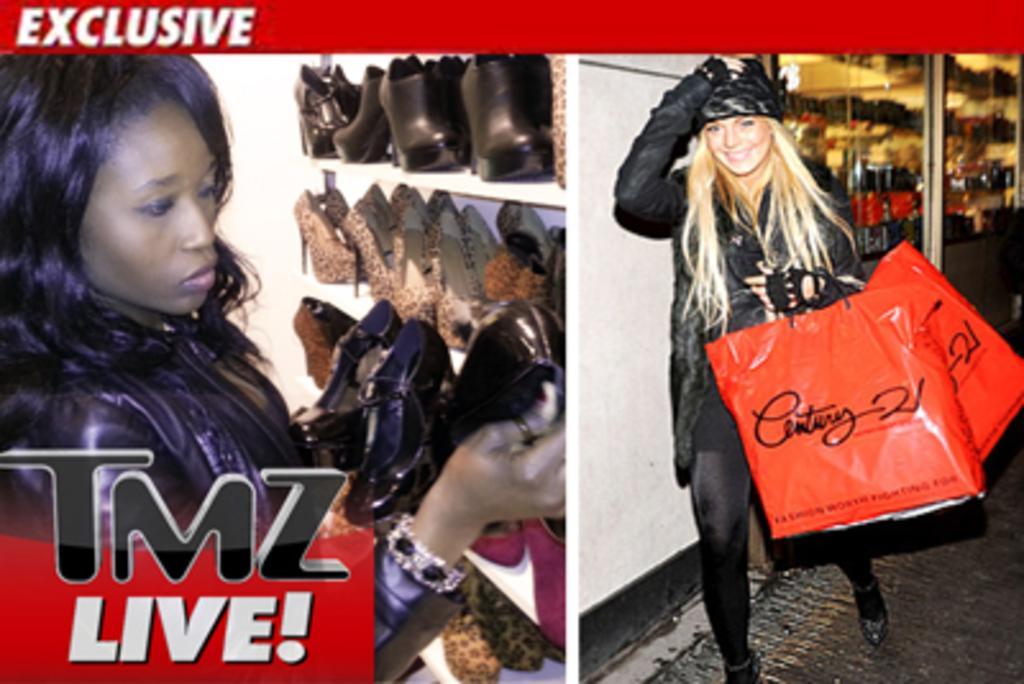Can you describe this image briefly? This is a collage image where we can see a woman standing and holding covers on the right side of this image. And there is one other woman holding shoes on the left side of this image. There is a watermark logo at the bottom of this image and at the top of this image as well. 